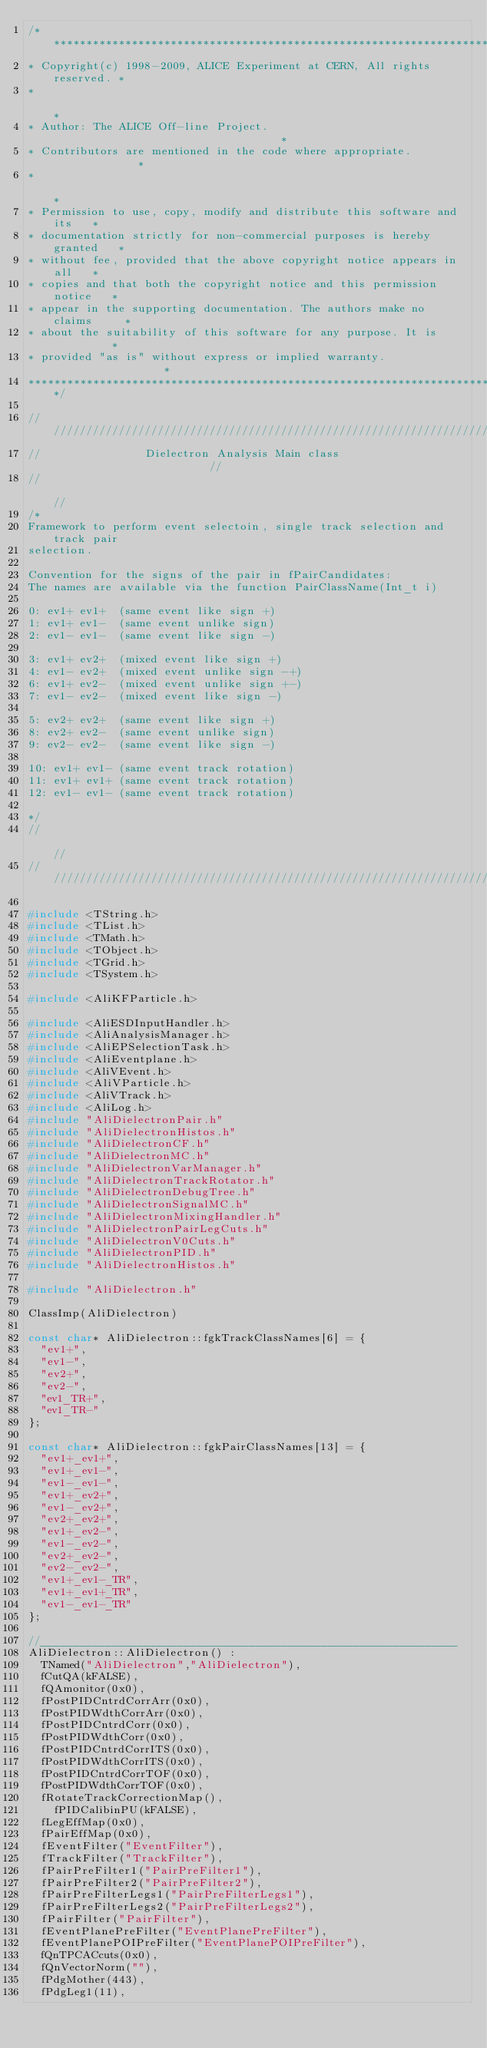Convert code to text. <code><loc_0><loc_0><loc_500><loc_500><_C++_>/*************************************************************************
* Copyright(c) 1998-2009, ALICE Experiment at CERN, All rights reserved. *
*                                                                        *
* Author: The ALICE Off-line Project.                                    *
* Contributors are mentioned in the code where appropriate.              *
*                                                                        *
* Permission to use, copy, modify and distribute this software and its   *
* documentation strictly for non-commercial purposes is hereby granted   *
* without fee, provided that the above copyright notice appears in all   *
* copies and that both the copyright notice and this permission notice   *
* appear in the supporting documentation. The authors make no claims     *
* about the suitability of this software for any purpose. It is          *
* provided "as is" without express or implied warranty.                  *
**************************************************************************/

///////////////////////////////////////////////////////////////////////////
//                Dielectron Analysis Main class                         //
//                                                                       //
/*
Framework to perform event selectoin, single track selection and track pair
selection.

Convention for the signs of the pair in fPairCandidates:
The names are available via the function PairClassName(Int_t i)

0: ev1+ ev1+  (same event like sign +)
1: ev1+ ev1-  (same event unlike sign)
2: ev1- ev1-  (same event like sign -)

3: ev1+ ev2+  (mixed event like sign +)
4: ev1- ev2+  (mixed event unlike sign -+)
6: ev1+ ev2-  (mixed event unlike sign +-)
7: ev1- ev2-  (mixed event like sign -)

5: ev2+ ev2+  (same event like sign +)
8: ev2+ ev2-  (same event unlike sign)
9: ev2- ev2-  (same event like sign -)

10: ev1+ ev1- (same event track rotation)
11: ev1+ ev1+ (same event track rotation)
12: ev1- ev1- (same event track rotation)

*/
//                                                                       //
///////////////////////////////////////////////////////////////////////////

#include <TString.h>
#include <TList.h>
#include <TMath.h>
#include <TObject.h>
#include <TGrid.h>
#include <TSystem.h>

#include <AliKFParticle.h>

#include <AliESDInputHandler.h>
#include <AliAnalysisManager.h>
#include <AliEPSelectionTask.h>
#include <AliEventplane.h>
#include <AliVEvent.h>
#include <AliVParticle.h>
#include <AliVTrack.h>
#include <AliLog.h>
#include "AliDielectronPair.h"
#include "AliDielectronHistos.h"
#include "AliDielectronCF.h"
#include "AliDielectronMC.h"
#include "AliDielectronVarManager.h"
#include "AliDielectronTrackRotator.h"
#include "AliDielectronDebugTree.h"
#include "AliDielectronSignalMC.h"
#include "AliDielectronMixingHandler.h"
#include "AliDielectronPairLegCuts.h"
#include "AliDielectronV0Cuts.h"
#include "AliDielectronPID.h"
#include "AliDielectronHistos.h"

#include "AliDielectron.h"

ClassImp(AliDielectron)

const char* AliDielectron::fgkTrackClassNames[6] = {
  "ev1+",
  "ev1-",
  "ev2+",
  "ev2-",
  "ev1_TR+",
  "ev1_TR-"
};

const char* AliDielectron::fgkPairClassNames[13] = {
  "ev1+_ev1+",
  "ev1+_ev1-",
  "ev1-_ev1-",
  "ev1+_ev2+",
  "ev1-_ev2+",
  "ev2+_ev2+",
  "ev1+_ev2-",
  "ev1-_ev2-",
  "ev2+_ev2-",
  "ev2-_ev2-",
  "ev1+_ev1-_TR",
  "ev1+_ev1+_TR",
  "ev1-_ev1-_TR"
};

//________________________________________________________________
AliDielectron::AliDielectron() :
  TNamed("AliDielectron","AliDielectron"),
  fCutQA(kFALSE),
  fQAmonitor(0x0),
  fPostPIDCntrdCorrArr(0x0),
  fPostPIDWdthCorrArr(0x0),
  fPostPIDCntrdCorr(0x0),
  fPostPIDWdthCorr(0x0),
  fPostPIDCntrdCorrITS(0x0),
  fPostPIDWdthCorrITS(0x0),
  fPostPIDCntrdCorrTOF(0x0),
  fPostPIDWdthCorrTOF(0x0),
  fRotateTrackCorrectionMap(),
	fPIDCalibinPU(kFALSE),
  fLegEffMap(0x0),
  fPairEffMap(0x0),
  fEventFilter("EventFilter"),
  fTrackFilter("TrackFilter"),
  fPairPreFilter1("PairPreFilter1"),
  fPairPreFilter2("PairPreFilter2"),
  fPairPreFilterLegs1("PairPreFilterLegs1"),
  fPairPreFilterLegs2("PairPreFilterLegs2"),
  fPairFilter("PairFilter"),
  fEventPlanePreFilter("EventPlanePreFilter"),
  fEventPlanePOIPreFilter("EventPlanePOIPreFilter"),
  fQnTPCACcuts(0x0),
  fQnVectorNorm(""),
  fPdgMother(443),
  fPdgLeg1(11),</code> 